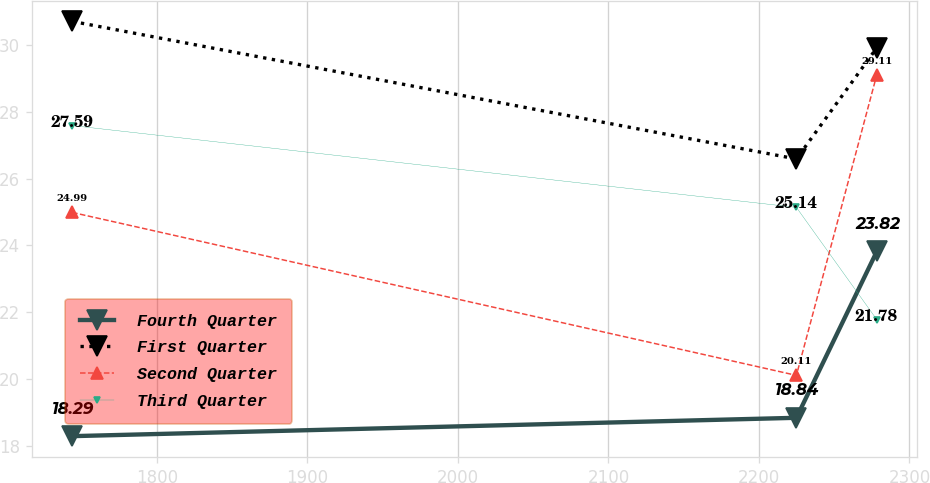Convert chart to OTSL. <chart><loc_0><loc_0><loc_500><loc_500><line_chart><ecel><fcel>Fourth Quarter<fcel>First Quarter<fcel>Second Quarter<fcel>Third Quarter<nl><fcel>1743.63<fcel>18.29<fcel>30.71<fcel>24.99<fcel>27.59<nl><fcel>2224.89<fcel>18.84<fcel>26.59<fcel>20.11<fcel>25.14<nl><fcel>2278.32<fcel>23.82<fcel>29.92<fcel>29.11<fcel>21.78<nl></chart> 